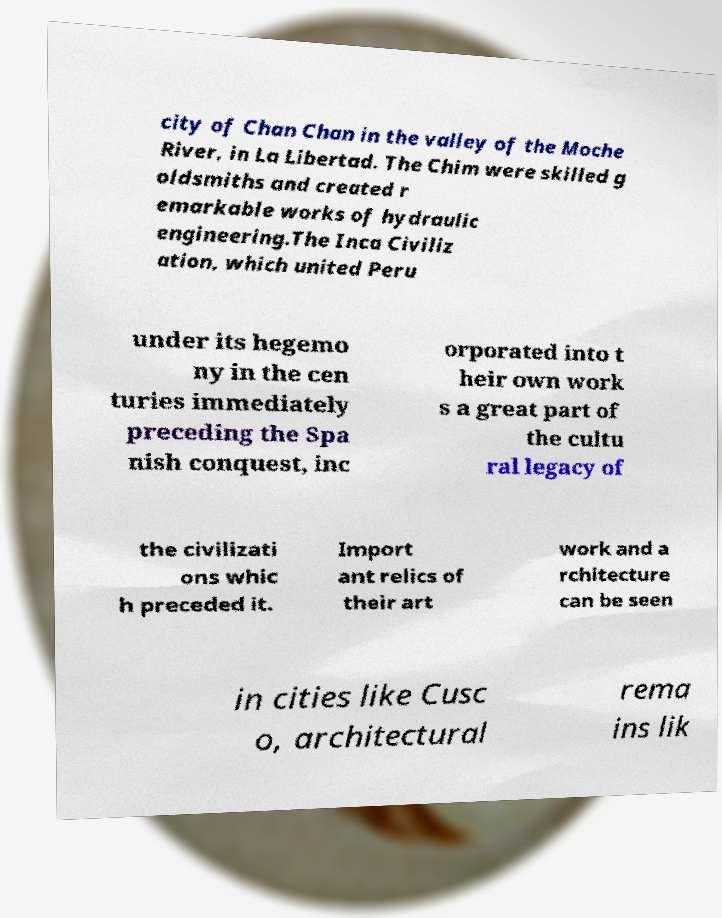Could you assist in decoding the text presented in this image and type it out clearly? city of Chan Chan in the valley of the Moche River, in La Libertad. The Chim were skilled g oldsmiths and created r emarkable works of hydraulic engineering.The Inca Civiliz ation, which united Peru under its hegemo ny in the cen turies immediately preceding the Spa nish conquest, inc orporated into t heir own work s a great part of the cultu ral legacy of the civilizati ons whic h preceded it. Import ant relics of their art work and a rchitecture can be seen in cities like Cusc o, architectural rema ins lik 